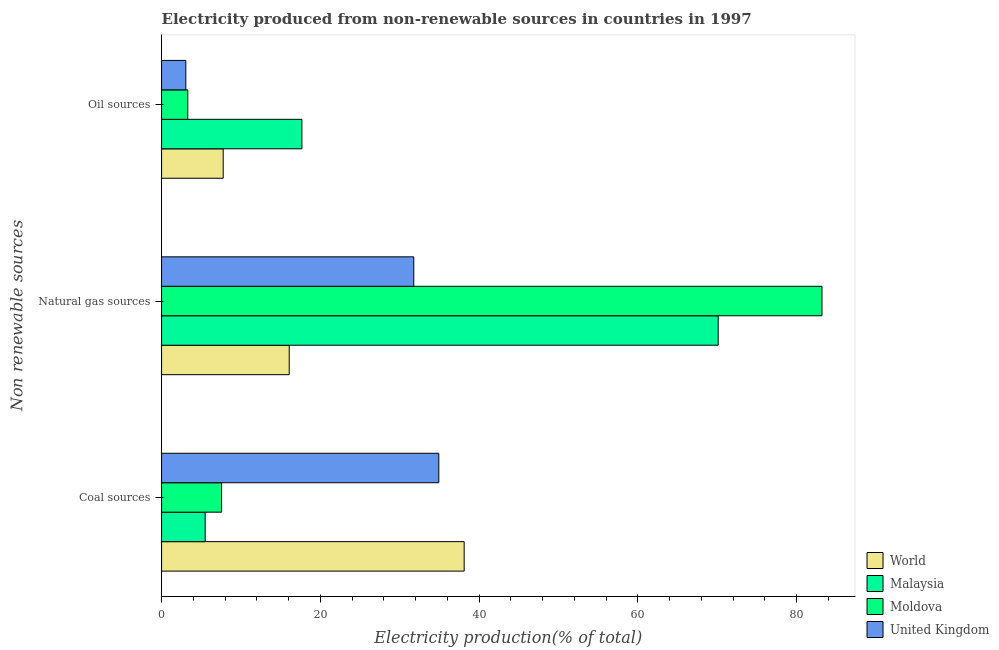How many different coloured bars are there?
Provide a short and direct response. 4. How many groups of bars are there?
Make the answer very short. 3. Are the number of bars per tick equal to the number of legend labels?
Provide a succinct answer. Yes. Are the number of bars on each tick of the Y-axis equal?
Your answer should be compact. Yes. How many bars are there on the 2nd tick from the top?
Offer a very short reply. 4. What is the label of the 3rd group of bars from the top?
Your answer should be compact. Coal sources. What is the percentage of electricity produced by natural gas in United Kingdom?
Your answer should be very brief. 31.78. Across all countries, what is the maximum percentage of electricity produced by natural gas?
Provide a succinct answer. 83.21. Across all countries, what is the minimum percentage of electricity produced by coal?
Offer a very short reply. 5.49. In which country was the percentage of electricity produced by oil sources maximum?
Your answer should be very brief. Malaysia. In which country was the percentage of electricity produced by coal minimum?
Ensure brevity in your answer.  Malaysia. What is the total percentage of electricity produced by oil sources in the graph?
Offer a very short reply. 31.8. What is the difference between the percentage of electricity produced by coal in Malaysia and that in Moldova?
Give a very brief answer. -2.07. What is the difference between the percentage of electricity produced by natural gas in Moldova and the percentage of electricity produced by coal in World?
Offer a very short reply. 45.08. What is the average percentage of electricity produced by natural gas per country?
Your response must be concise. 50.3. What is the difference between the percentage of electricity produced by oil sources and percentage of electricity produced by natural gas in Moldova?
Your answer should be compact. -79.91. What is the ratio of the percentage of electricity produced by natural gas in World to that in United Kingdom?
Your answer should be very brief. 0.51. Is the percentage of electricity produced by natural gas in Malaysia less than that in World?
Offer a very short reply. No. Is the difference between the percentage of electricity produced by natural gas in Malaysia and Moldova greater than the difference between the percentage of electricity produced by coal in Malaysia and Moldova?
Offer a very short reply. No. What is the difference between the highest and the second highest percentage of electricity produced by coal?
Offer a very short reply. 3.2. What is the difference between the highest and the lowest percentage of electricity produced by coal?
Offer a very short reply. 32.63. In how many countries, is the percentage of electricity produced by oil sources greater than the average percentage of electricity produced by oil sources taken over all countries?
Make the answer very short. 1. How many bars are there?
Provide a succinct answer. 12. Are all the bars in the graph horizontal?
Your answer should be compact. Yes. How many countries are there in the graph?
Provide a succinct answer. 4. What is the difference between two consecutive major ticks on the X-axis?
Offer a terse response. 20. Are the values on the major ticks of X-axis written in scientific E-notation?
Provide a short and direct response. No. Does the graph contain any zero values?
Offer a terse response. No. How many legend labels are there?
Your answer should be compact. 4. How are the legend labels stacked?
Give a very brief answer. Vertical. What is the title of the graph?
Make the answer very short. Electricity produced from non-renewable sources in countries in 1997. What is the label or title of the X-axis?
Give a very brief answer. Electricity production(% of total). What is the label or title of the Y-axis?
Your answer should be compact. Non renewable sources. What is the Electricity production(% of total) in World in Coal sources?
Your answer should be very brief. 38.13. What is the Electricity production(% of total) in Malaysia in Coal sources?
Make the answer very short. 5.49. What is the Electricity production(% of total) of Moldova in Coal sources?
Give a very brief answer. 7.56. What is the Electricity production(% of total) of United Kingdom in Coal sources?
Provide a short and direct response. 34.93. What is the Electricity production(% of total) in World in Natural gas sources?
Offer a terse response. 16.08. What is the Electricity production(% of total) in Malaysia in Natural gas sources?
Offer a very short reply. 70.13. What is the Electricity production(% of total) of Moldova in Natural gas sources?
Make the answer very short. 83.21. What is the Electricity production(% of total) of United Kingdom in Natural gas sources?
Provide a succinct answer. 31.78. What is the Electricity production(% of total) in World in Oil sources?
Offer a very short reply. 7.76. What is the Electricity production(% of total) of Malaysia in Oil sources?
Your response must be concise. 17.68. What is the Electricity production(% of total) in Moldova in Oil sources?
Provide a succinct answer. 3.3. What is the Electricity production(% of total) of United Kingdom in Oil sources?
Your response must be concise. 3.06. Across all Non renewable sources, what is the maximum Electricity production(% of total) of World?
Your answer should be very brief. 38.13. Across all Non renewable sources, what is the maximum Electricity production(% of total) of Malaysia?
Your answer should be very brief. 70.13. Across all Non renewable sources, what is the maximum Electricity production(% of total) in Moldova?
Ensure brevity in your answer.  83.21. Across all Non renewable sources, what is the maximum Electricity production(% of total) in United Kingdom?
Provide a succinct answer. 34.93. Across all Non renewable sources, what is the minimum Electricity production(% of total) in World?
Offer a very short reply. 7.76. Across all Non renewable sources, what is the minimum Electricity production(% of total) in Malaysia?
Provide a short and direct response. 5.49. Across all Non renewable sources, what is the minimum Electricity production(% of total) in Moldova?
Your answer should be very brief. 3.3. Across all Non renewable sources, what is the minimum Electricity production(% of total) in United Kingdom?
Offer a terse response. 3.06. What is the total Electricity production(% of total) in World in the graph?
Offer a terse response. 61.97. What is the total Electricity production(% of total) in Malaysia in the graph?
Make the answer very short. 93.31. What is the total Electricity production(% of total) in Moldova in the graph?
Ensure brevity in your answer.  94.08. What is the total Electricity production(% of total) in United Kingdom in the graph?
Keep it short and to the point. 69.76. What is the difference between the Electricity production(% of total) in World in Coal sources and that in Natural gas sources?
Provide a short and direct response. 22.05. What is the difference between the Electricity production(% of total) in Malaysia in Coal sources and that in Natural gas sources?
Offer a very short reply. -64.64. What is the difference between the Electricity production(% of total) in Moldova in Coal sources and that in Natural gas sources?
Provide a short and direct response. -75.65. What is the difference between the Electricity production(% of total) of United Kingdom in Coal sources and that in Natural gas sources?
Provide a succinct answer. 3.15. What is the difference between the Electricity production(% of total) in World in Coal sources and that in Oil sources?
Your answer should be compact. 30.36. What is the difference between the Electricity production(% of total) in Malaysia in Coal sources and that in Oil sources?
Offer a terse response. -12.19. What is the difference between the Electricity production(% of total) in Moldova in Coal sources and that in Oil sources?
Give a very brief answer. 4.26. What is the difference between the Electricity production(% of total) of United Kingdom in Coal sources and that in Oil sources?
Ensure brevity in your answer.  31.88. What is the difference between the Electricity production(% of total) of World in Natural gas sources and that in Oil sources?
Give a very brief answer. 8.32. What is the difference between the Electricity production(% of total) of Malaysia in Natural gas sources and that in Oil sources?
Provide a succinct answer. 52.45. What is the difference between the Electricity production(% of total) of Moldova in Natural gas sources and that in Oil sources?
Offer a terse response. 79.91. What is the difference between the Electricity production(% of total) of United Kingdom in Natural gas sources and that in Oil sources?
Your answer should be very brief. 28.72. What is the difference between the Electricity production(% of total) of World in Coal sources and the Electricity production(% of total) of Malaysia in Natural gas sources?
Offer a very short reply. -32. What is the difference between the Electricity production(% of total) in World in Coal sources and the Electricity production(% of total) in Moldova in Natural gas sources?
Your response must be concise. -45.08. What is the difference between the Electricity production(% of total) of World in Coal sources and the Electricity production(% of total) of United Kingdom in Natural gas sources?
Provide a succinct answer. 6.35. What is the difference between the Electricity production(% of total) in Malaysia in Coal sources and the Electricity production(% of total) in Moldova in Natural gas sources?
Provide a short and direct response. -77.72. What is the difference between the Electricity production(% of total) in Malaysia in Coal sources and the Electricity production(% of total) in United Kingdom in Natural gas sources?
Offer a very short reply. -26.28. What is the difference between the Electricity production(% of total) of Moldova in Coal sources and the Electricity production(% of total) of United Kingdom in Natural gas sources?
Provide a short and direct response. -24.21. What is the difference between the Electricity production(% of total) in World in Coal sources and the Electricity production(% of total) in Malaysia in Oil sources?
Your answer should be compact. 20.45. What is the difference between the Electricity production(% of total) of World in Coal sources and the Electricity production(% of total) of Moldova in Oil sources?
Provide a succinct answer. 34.83. What is the difference between the Electricity production(% of total) of World in Coal sources and the Electricity production(% of total) of United Kingdom in Oil sources?
Give a very brief answer. 35.07. What is the difference between the Electricity production(% of total) of Malaysia in Coal sources and the Electricity production(% of total) of Moldova in Oil sources?
Your answer should be very brief. 2.19. What is the difference between the Electricity production(% of total) in Malaysia in Coal sources and the Electricity production(% of total) in United Kingdom in Oil sources?
Give a very brief answer. 2.44. What is the difference between the Electricity production(% of total) in Moldova in Coal sources and the Electricity production(% of total) in United Kingdom in Oil sources?
Ensure brevity in your answer.  4.51. What is the difference between the Electricity production(% of total) in World in Natural gas sources and the Electricity production(% of total) in Malaysia in Oil sources?
Your answer should be compact. -1.6. What is the difference between the Electricity production(% of total) of World in Natural gas sources and the Electricity production(% of total) of Moldova in Oil sources?
Your answer should be compact. 12.78. What is the difference between the Electricity production(% of total) in World in Natural gas sources and the Electricity production(% of total) in United Kingdom in Oil sources?
Keep it short and to the point. 13.03. What is the difference between the Electricity production(% of total) in Malaysia in Natural gas sources and the Electricity production(% of total) in Moldova in Oil sources?
Offer a very short reply. 66.83. What is the difference between the Electricity production(% of total) of Malaysia in Natural gas sources and the Electricity production(% of total) of United Kingdom in Oil sources?
Your response must be concise. 67.08. What is the difference between the Electricity production(% of total) of Moldova in Natural gas sources and the Electricity production(% of total) of United Kingdom in Oil sources?
Give a very brief answer. 80.16. What is the average Electricity production(% of total) in World per Non renewable sources?
Offer a terse response. 20.66. What is the average Electricity production(% of total) in Malaysia per Non renewable sources?
Your answer should be compact. 31.1. What is the average Electricity production(% of total) in Moldova per Non renewable sources?
Ensure brevity in your answer.  31.36. What is the average Electricity production(% of total) in United Kingdom per Non renewable sources?
Ensure brevity in your answer.  23.25. What is the difference between the Electricity production(% of total) of World and Electricity production(% of total) of Malaysia in Coal sources?
Your answer should be compact. 32.63. What is the difference between the Electricity production(% of total) of World and Electricity production(% of total) of Moldova in Coal sources?
Provide a succinct answer. 30.56. What is the difference between the Electricity production(% of total) of World and Electricity production(% of total) of United Kingdom in Coal sources?
Ensure brevity in your answer.  3.2. What is the difference between the Electricity production(% of total) of Malaysia and Electricity production(% of total) of Moldova in Coal sources?
Keep it short and to the point. -2.07. What is the difference between the Electricity production(% of total) of Malaysia and Electricity production(% of total) of United Kingdom in Coal sources?
Give a very brief answer. -29.44. What is the difference between the Electricity production(% of total) of Moldova and Electricity production(% of total) of United Kingdom in Coal sources?
Keep it short and to the point. -27.37. What is the difference between the Electricity production(% of total) of World and Electricity production(% of total) of Malaysia in Natural gas sources?
Offer a terse response. -54.05. What is the difference between the Electricity production(% of total) in World and Electricity production(% of total) in Moldova in Natural gas sources?
Your response must be concise. -67.13. What is the difference between the Electricity production(% of total) of World and Electricity production(% of total) of United Kingdom in Natural gas sources?
Ensure brevity in your answer.  -15.7. What is the difference between the Electricity production(% of total) of Malaysia and Electricity production(% of total) of Moldova in Natural gas sources?
Offer a very short reply. -13.08. What is the difference between the Electricity production(% of total) in Malaysia and Electricity production(% of total) in United Kingdom in Natural gas sources?
Your answer should be compact. 38.35. What is the difference between the Electricity production(% of total) of Moldova and Electricity production(% of total) of United Kingdom in Natural gas sources?
Offer a terse response. 51.43. What is the difference between the Electricity production(% of total) of World and Electricity production(% of total) of Malaysia in Oil sources?
Your answer should be compact. -9.92. What is the difference between the Electricity production(% of total) in World and Electricity production(% of total) in Moldova in Oil sources?
Your answer should be very brief. 4.46. What is the difference between the Electricity production(% of total) of World and Electricity production(% of total) of United Kingdom in Oil sources?
Make the answer very short. 4.71. What is the difference between the Electricity production(% of total) of Malaysia and Electricity production(% of total) of Moldova in Oil sources?
Ensure brevity in your answer.  14.38. What is the difference between the Electricity production(% of total) in Malaysia and Electricity production(% of total) in United Kingdom in Oil sources?
Keep it short and to the point. 14.63. What is the difference between the Electricity production(% of total) in Moldova and Electricity production(% of total) in United Kingdom in Oil sources?
Provide a short and direct response. 0.25. What is the ratio of the Electricity production(% of total) in World in Coal sources to that in Natural gas sources?
Offer a terse response. 2.37. What is the ratio of the Electricity production(% of total) in Malaysia in Coal sources to that in Natural gas sources?
Offer a terse response. 0.08. What is the ratio of the Electricity production(% of total) of Moldova in Coal sources to that in Natural gas sources?
Your answer should be very brief. 0.09. What is the ratio of the Electricity production(% of total) of United Kingdom in Coal sources to that in Natural gas sources?
Ensure brevity in your answer.  1.1. What is the ratio of the Electricity production(% of total) in World in Coal sources to that in Oil sources?
Your answer should be compact. 4.91. What is the ratio of the Electricity production(% of total) of Malaysia in Coal sources to that in Oil sources?
Your response must be concise. 0.31. What is the ratio of the Electricity production(% of total) in Moldova in Coal sources to that in Oil sources?
Your response must be concise. 2.29. What is the ratio of the Electricity production(% of total) of United Kingdom in Coal sources to that in Oil sources?
Your answer should be compact. 11.43. What is the ratio of the Electricity production(% of total) in World in Natural gas sources to that in Oil sources?
Your answer should be compact. 2.07. What is the ratio of the Electricity production(% of total) in Malaysia in Natural gas sources to that in Oil sources?
Provide a short and direct response. 3.97. What is the ratio of the Electricity production(% of total) in Moldova in Natural gas sources to that in Oil sources?
Your answer should be compact. 25.2. What is the ratio of the Electricity production(% of total) of United Kingdom in Natural gas sources to that in Oil sources?
Keep it short and to the point. 10.4. What is the difference between the highest and the second highest Electricity production(% of total) in World?
Ensure brevity in your answer.  22.05. What is the difference between the highest and the second highest Electricity production(% of total) of Malaysia?
Offer a terse response. 52.45. What is the difference between the highest and the second highest Electricity production(% of total) in Moldova?
Give a very brief answer. 75.65. What is the difference between the highest and the second highest Electricity production(% of total) of United Kingdom?
Ensure brevity in your answer.  3.15. What is the difference between the highest and the lowest Electricity production(% of total) of World?
Keep it short and to the point. 30.36. What is the difference between the highest and the lowest Electricity production(% of total) of Malaysia?
Keep it short and to the point. 64.64. What is the difference between the highest and the lowest Electricity production(% of total) in Moldova?
Keep it short and to the point. 79.91. What is the difference between the highest and the lowest Electricity production(% of total) in United Kingdom?
Your response must be concise. 31.88. 